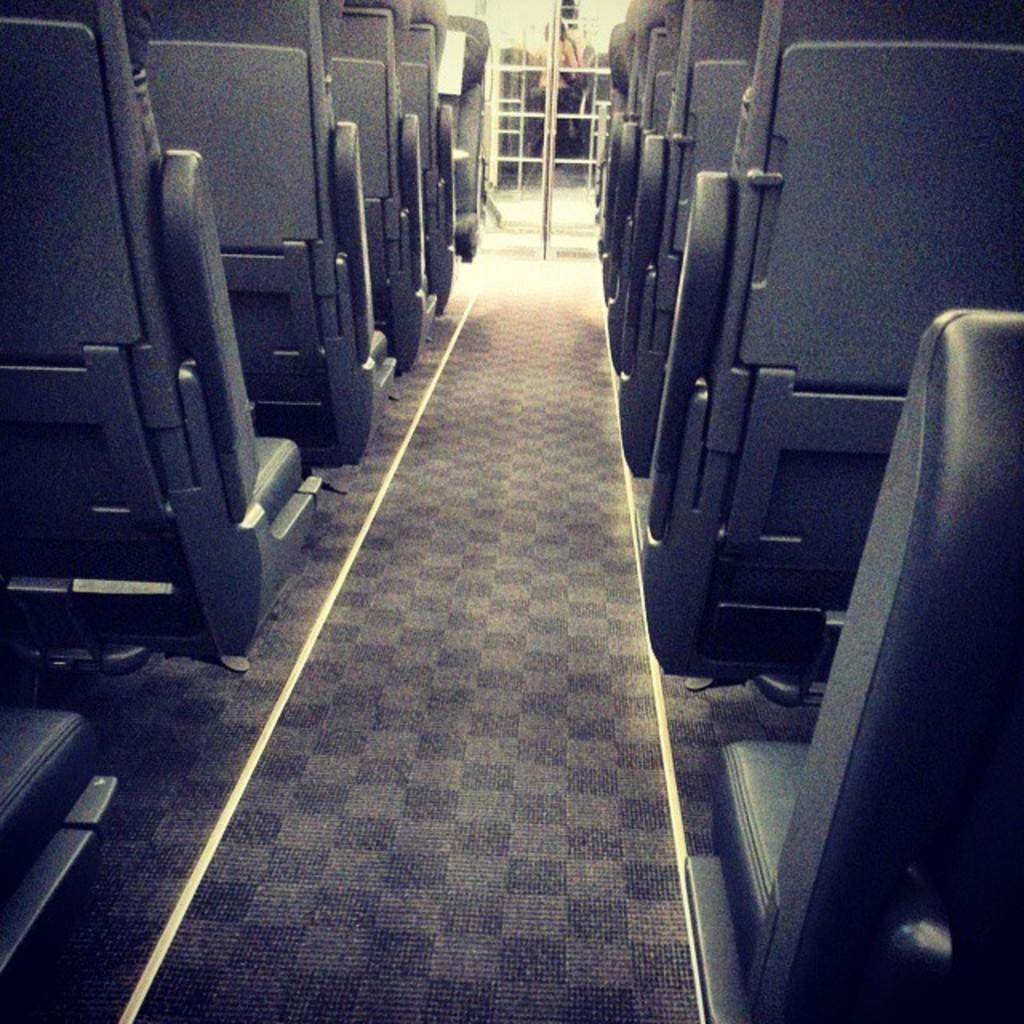How would you summarize this image in a sentence or two? On the left and right side of the image we can see group of seats. At the top of the image we can see some poles and a person is standing. 